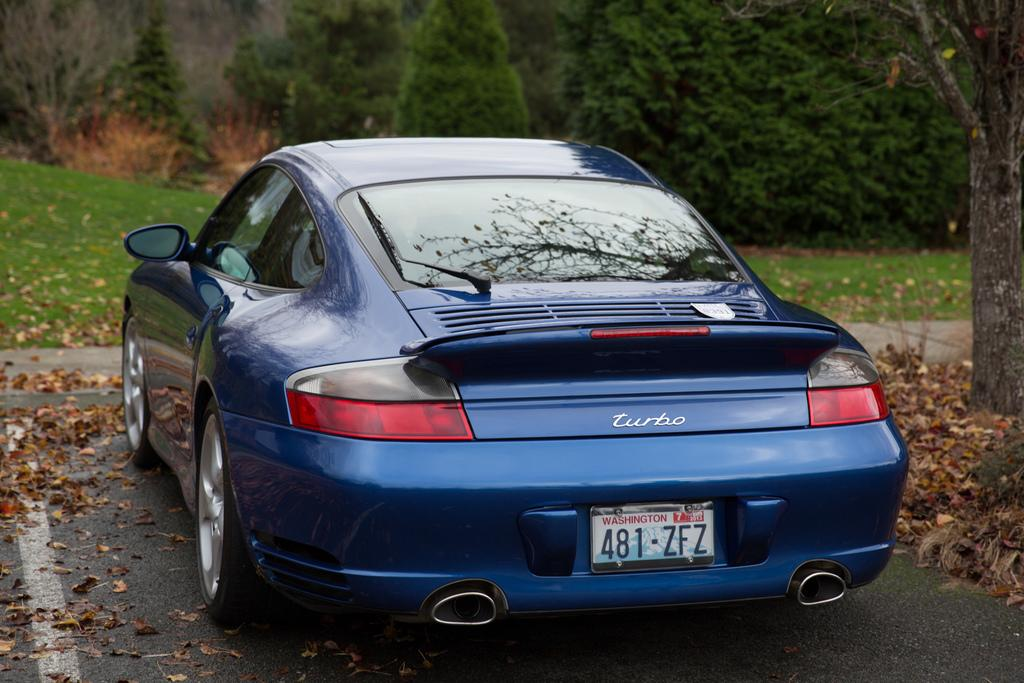<image>
Share a concise interpretation of the image provided. a Turbo car with Washington Plate 481 ZFZ on it 